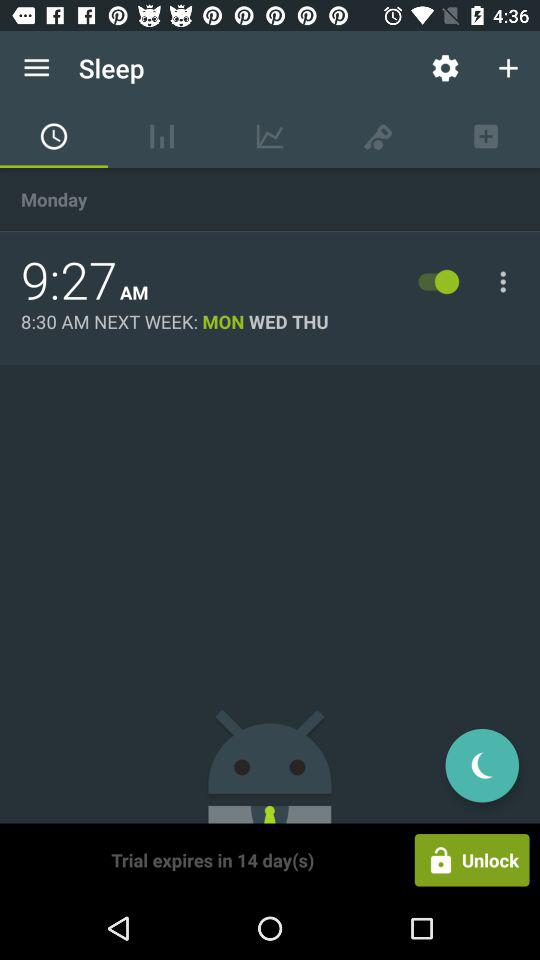In how many days will the trial expire? The trial will expire in 14 days. 